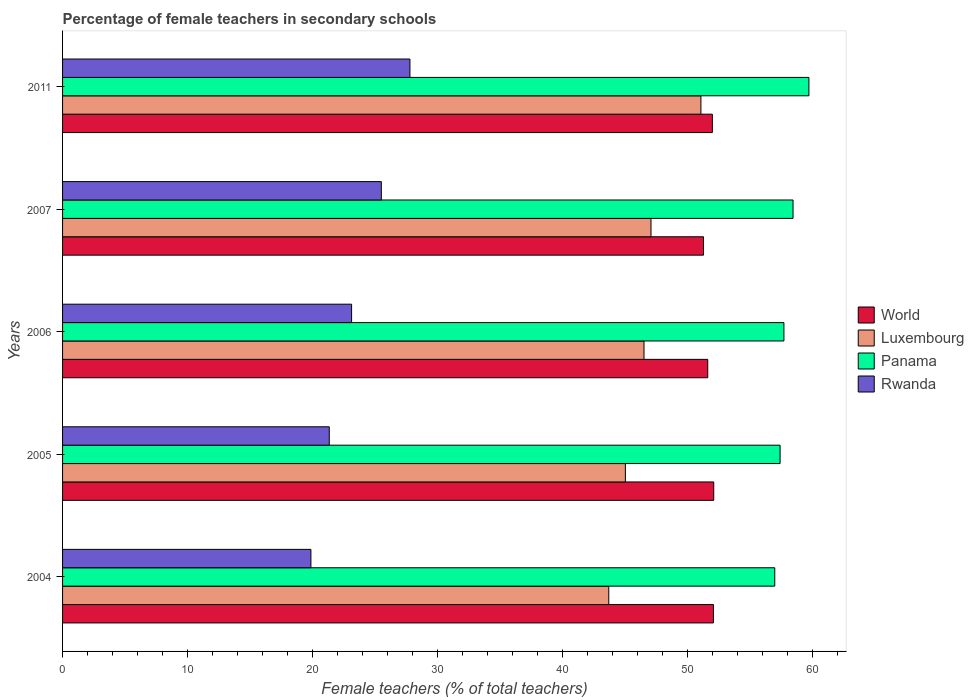How many groups of bars are there?
Your response must be concise. 5. Are the number of bars per tick equal to the number of legend labels?
Make the answer very short. Yes. Are the number of bars on each tick of the Y-axis equal?
Ensure brevity in your answer.  Yes. How many bars are there on the 5th tick from the top?
Keep it short and to the point. 4. How many bars are there on the 4th tick from the bottom?
Your answer should be very brief. 4. What is the label of the 4th group of bars from the top?
Give a very brief answer. 2005. What is the percentage of female teachers in Rwanda in 2004?
Give a very brief answer. 19.87. Across all years, what is the maximum percentage of female teachers in Rwanda?
Provide a succinct answer. 27.79. Across all years, what is the minimum percentage of female teachers in Rwanda?
Offer a very short reply. 19.87. In which year was the percentage of female teachers in Luxembourg maximum?
Provide a short and direct response. 2011. In which year was the percentage of female teachers in Panama minimum?
Your response must be concise. 2004. What is the total percentage of female teachers in Rwanda in the graph?
Ensure brevity in your answer.  117.64. What is the difference between the percentage of female teachers in Luxembourg in 2004 and that in 2007?
Provide a short and direct response. -3.38. What is the difference between the percentage of female teachers in World in 2004 and the percentage of female teachers in Luxembourg in 2005?
Your answer should be compact. 7.05. What is the average percentage of female teachers in Luxembourg per year?
Ensure brevity in your answer.  46.68. In the year 2004, what is the difference between the percentage of female teachers in Panama and percentage of female teachers in Rwanda?
Keep it short and to the point. 37.12. In how many years, is the percentage of female teachers in Rwanda greater than 50 %?
Your answer should be very brief. 0. What is the ratio of the percentage of female teachers in Panama in 2004 to that in 2011?
Offer a very short reply. 0.95. What is the difference between the highest and the second highest percentage of female teachers in Rwanda?
Your answer should be very brief. 2.29. What is the difference between the highest and the lowest percentage of female teachers in Rwanda?
Provide a succinct answer. 7.92. In how many years, is the percentage of female teachers in Panama greater than the average percentage of female teachers in Panama taken over all years?
Offer a terse response. 2. Is the sum of the percentage of female teachers in World in 2006 and 2007 greater than the maximum percentage of female teachers in Panama across all years?
Your answer should be compact. Yes. What does the 2nd bar from the top in 2007 represents?
Offer a terse response. Panama. What does the 3rd bar from the bottom in 2006 represents?
Offer a terse response. Panama. Is it the case that in every year, the sum of the percentage of female teachers in World and percentage of female teachers in Luxembourg is greater than the percentage of female teachers in Panama?
Offer a very short reply. Yes. What is the difference between two consecutive major ticks on the X-axis?
Ensure brevity in your answer.  10. Does the graph contain grids?
Your answer should be very brief. No. Where does the legend appear in the graph?
Give a very brief answer. Center right. What is the title of the graph?
Ensure brevity in your answer.  Percentage of female teachers in secondary schools. Does "Northern Mariana Islands" appear as one of the legend labels in the graph?
Provide a short and direct response. No. What is the label or title of the X-axis?
Your answer should be compact. Female teachers (% of total teachers). What is the Female teachers (% of total teachers) of World in 2004?
Offer a very short reply. 52.08. What is the Female teachers (% of total teachers) of Luxembourg in 2004?
Offer a very short reply. 43.7. What is the Female teachers (% of total teachers) of Panama in 2004?
Ensure brevity in your answer.  56.99. What is the Female teachers (% of total teachers) in Rwanda in 2004?
Ensure brevity in your answer.  19.87. What is the Female teachers (% of total teachers) of World in 2005?
Give a very brief answer. 52.1. What is the Female teachers (% of total teachers) of Luxembourg in 2005?
Your response must be concise. 45.03. What is the Female teachers (% of total teachers) in Panama in 2005?
Ensure brevity in your answer.  57.41. What is the Female teachers (% of total teachers) in Rwanda in 2005?
Ensure brevity in your answer.  21.34. What is the Female teachers (% of total teachers) of World in 2006?
Keep it short and to the point. 51.62. What is the Female teachers (% of total teachers) in Luxembourg in 2006?
Your response must be concise. 46.52. What is the Female teachers (% of total teachers) of Panama in 2006?
Your answer should be very brief. 57.72. What is the Female teachers (% of total teachers) in Rwanda in 2006?
Your response must be concise. 23.13. What is the Female teachers (% of total teachers) of World in 2007?
Offer a very short reply. 51.28. What is the Female teachers (% of total teachers) in Luxembourg in 2007?
Offer a very short reply. 47.08. What is the Female teachers (% of total teachers) in Panama in 2007?
Your response must be concise. 58.45. What is the Female teachers (% of total teachers) of Rwanda in 2007?
Offer a terse response. 25.51. What is the Female teachers (% of total teachers) in World in 2011?
Provide a succinct answer. 51.99. What is the Female teachers (% of total teachers) in Luxembourg in 2011?
Give a very brief answer. 51.08. What is the Female teachers (% of total teachers) in Panama in 2011?
Give a very brief answer. 59.72. What is the Female teachers (% of total teachers) of Rwanda in 2011?
Make the answer very short. 27.79. Across all years, what is the maximum Female teachers (% of total teachers) of World?
Your answer should be very brief. 52.1. Across all years, what is the maximum Female teachers (% of total teachers) of Luxembourg?
Provide a short and direct response. 51.08. Across all years, what is the maximum Female teachers (% of total teachers) in Panama?
Your answer should be compact. 59.72. Across all years, what is the maximum Female teachers (% of total teachers) of Rwanda?
Ensure brevity in your answer.  27.79. Across all years, what is the minimum Female teachers (% of total teachers) in World?
Provide a short and direct response. 51.28. Across all years, what is the minimum Female teachers (% of total teachers) in Luxembourg?
Offer a terse response. 43.7. Across all years, what is the minimum Female teachers (% of total teachers) in Panama?
Ensure brevity in your answer.  56.99. Across all years, what is the minimum Female teachers (% of total teachers) of Rwanda?
Offer a very short reply. 19.87. What is the total Female teachers (% of total teachers) in World in the graph?
Your answer should be very brief. 259.08. What is the total Female teachers (% of total teachers) in Luxembourg in the graph?
Offer a very short reply. 233.42. What is the total Female teachers (% of total teachers) of Panama in the graph?
Your answer should be compact. 290.29. What is the total Female teachers (% of total teachers) of Rwanda in the graph?
Make the answer very short. 117.64. What is the difference between the Female teachers (% of total teachers) in World in 2004 and that in 2005?
Your response must be concise. -0.02. What is the difference between the Female teachers (% of total teachers) of Luxembourg in 2004 and that in 2005?
Keep it short and to the point. -1.33. What is the difference between the Female teachers (% of total teachers) in Panama in 2004 and that in 2005?
Ensure brevity in your answer.  -0.43. What is the difference between the Female teachers (% of total teachers) in Rwanda in 2004 and that in 2005?
Ensure brevity in your answer.  -1.47. What is the difference between the Female teachers (% of total teachers) of World in 2004 and that in 2006?
Keep it short and to the point. 0.45. What is the difference between the Female teachers (% of total teachers) in Luxembourg in 2004 and that in 2006?
Provide a succinct answer. -2.82. What is the difference between the Female teachers (% of total teachers) of Panama in 2004 and that in 2006?
Your answer should be compact. -0.73. What is the difference between the Female teachers (% of total teachers) of Rwanda in 2004 and that in 2006?
Your response must be concise. -3.26. What is the difference between the Female teachers (% of total teachers) of World in 2004 and that in 2007?
Your answer should be very brief. 0.8. What is the difference between the Female teachers (% of total teachers) in Luxembourg in 2004 and that in 2007?
Your answer should be compact. -3.38. What is the difference between the Female teachers (% of total teachers) of Panama in 2004 and that in 2007?
Offer a terse response. -1.46. What is the difference between the Female teachers (% of total teachers) in Rwanda in 2004 and that in 2007?
Give a very brief answer. -5.64. What is the difference between the Female teachers (% of total teachers) in World in 2004 and that in 2011?
Make the answer very short. 0.09. What is the difference between the Female teachers (% of total teachers) in Luxembourg in 2004 and that in 2011?
Give a very brief answer. -7.37. What is the difference between the Female teachers (% of total teachers) in Panama in 2004 and that in 2011?
Offer a very short reply. -2.73. What is the difference between the Female teachers (% of total teachers) of Rwanda in 2004 and that in 2011?
Make the answer very short. -7.92. What is the difference between the Female teachers (% of total teachers) in World in 2005 and that in 2006?
Keep it short and to the point. 0.48. What is the difference between the Female teachers (% of total teachers) in Luxembourg in 2005 and that in 2006?
Keep it short and to the point. -1.49. What is the difference between the Female teachers (% of total teachers) in Panama in 2005 and that in 2006?
Offer a very short reply. -0.31. What is the difference between the Female teachers (% of total teachers) of Rwanda in 2005 and that in 2006?
Your response must be concise. -1.79. What is the difference between the Female teachers (% of total teachers) of World in 2005 and that in 2007?
Offer a very short reply. 0.82. What is the difference between the Female teachers (% of total teachers) of Luxembourg in 2005 and that in 2007?
Your answer should be compact. -2.05. What is the difference between the Female teachers (% of total teachers) in Panama in 2005 and that in 2007?
Provide a succinct answer. -1.04. What is the difference between the Female teachers (% of total teachers) in Rwanda in 2005 and that in 2007?
Offer a very short reply. -4.17. What is the difference between the Female teachers (% of total teachers) of World in 2005 and that in 2011?
Make the answer very short. 0.11. What is the difference between the Female teachers (% of total teachers) in Luxembourg in 2005 and that in 2011?
Make the answer very short. -6.05. What is the difference between the Female teachers (% of total teachers) of Panama in 2005 and that in 2011?
Ensure brevity in your answer.  -2.31. What is the difference between the Female teachers (% of total teachers) of Rwanda in 2005 and that in 2011?
Offer a terse response. -6.45. What is the difference between the Female teachers (% of total teachers) in World in 2006 and that in 2007?
Keep it short and to the point. 0.34. What is the difference between the Female teachers (% of total teachers) of Luxembourg in 2006 and that in 2007?
Offer a very short reply. -0.56. What is the difference between the Female teachers (% of total teachers) in Panama in 2006 and that in 2007?
Make the answer very short. -0.73. What is the difference between the Female teachers (% of total teachers) in Rwanda in 2006 and that in 2007?
Offer a very short reply. -2.38. What is the difference between the Female teachers (% of total teachers) in World in 2006 and that in 2011?
Your response must be concise. -0.37. What is the difference between the Female teachers (% of total teachers) in Luxembourg in 2006 and that in 2011?
Make the answer very short. -4.56. What is the difference between the Female teachers (% of total teachers) in Panama in 2006 and that in 2011?
Offer a very short reply. -2. What is the difference between the Female teachers (% of total teachers) of Rwanda in 2006 and that in 2011?
Make the answer very short. -4.67. What is the difference between the Female teachers (% of total teachers) of World in 2007 and that in 2011?
Your response must be concise. -0.71. What is the difference between the Female teachers (% of total teachers) in Luxembourg in 2007 and that in 2011?
Offer a very short reply. -3.99. What is the difference between the Female teachers (% of total teachers) in Panama in 2007 and that in 2011?
Ensure brevity in your answer.  -1.27. What is the difference between the Female teachers (% of total teachers) in Rwanda in 2007 and that in 2011?
Offer a very short reply. -2.29. What is the difference between the Female teachers (% of total teachers) of World in 2004 and the Female teachers (% of total teachers) of Luxembourg in 2005?
Offer a very short reply. 7.05. What is the difference between the Female teachers (% of total teachers) in World in 2004 and the Female teachers (% of total teachers) in Panama in 2005?
Your answer should be compact. -5.33. What is the difference between the Female teachers (% of total teachers) in World in 2004 and the Female teachers (% of total teachers) in Rwanda in 2005?
Ensure brevity in your answer.  30.74. What is the difference between the Female teachers (% of total teachers) of Luxembourg in 2004 and the Female teachers (% of total teachers) of Panama in 2005?
Give a very brief answer. -13.71. What is the difference between the Female teachers (% of total teachers) in Luxembourg in 2004 and the Female teachers (% of total teachers) in Rwanda in 2005?
Keep it short and to the point. 22.36. What is the difference between the Female teachers (% of total teachers) of Panama in 2004 and the Female teachers (% of total teachers) of Rwanda in 2005?
Give a very brief answer. 35.65. What is the difference between the Female teachers (% of total teachers) in World in 2004 and the Female teachers (% of total teachers) in Luxembourg in 2006?
Your answer should be compact. 5.56. What is the difference between the Female teachers (% of total teachers) in World in 2004 and the Female teachers (% of total teachers) in Panama in 2006?
Offer a very short reply. -5.64. What is the difference between the Female teachers (% of total teachers) of World in 2004 and the Female teachers (% of total teachers) of Rwanda in 2006?
Ensure brevity in your answer.  28.95. What is the difference between the Female teachers (% of total teachers) in Luxembourg in 2004 and the Female teachers (% of total teachers) in Panama in 2006?
Make the answer very short. -14.02. What is the difference between the Female teachers (% of total teachers) in Luxembourg in 2004 and the Female teachers (% of total teachers) in Rwanda in 2006?
Keep it short and to the point. 20.58. What is the difference between the Female teachers (% of total teachers) of Panama in 2004 and the Female teachers (% of total teachers) of Rwanda in 2006?
Provide a short and direct response. 33.86. What is the difference between the Female teachers (% of total teachers) in World in 2004 and the Female teachers (% of total teachers) in Luxembourg in 2007?
Ensure brevity in your answer.  5. What is the difference between the Female teachers (% of total teachers) of World in 2004 and the Female teachers (% of total teachers) of Panama in 2007?
Ensure brevity in your answer.  -6.37. What is the difference between the Female teachers (% of total teachers) of World in 2004 and the Female teachers (% of total teachers) of Rwanda in 2007?
Your answer should be very brief. 26.57. What is the difference between the Female teachers (% of total teachers) in Luxembourg in 2004 and the Female teachers (% of total teachers) in Panama in 2007?
Provide a succinct answer. -14.75. What is the difference between the Female teachers (% of total teachers) of Luxembourg in 2004 and the Female teachers (% of total teachers) of Rwanda in 2007?
Offer a terse response. 18.2. What is the difference between the Female teachers (% of total teachers) of Panama in 2004 and the Female teachers (% of total teachers) of Rwanda in 2007?
Provide a short and direct response. 31.48. What is the difference between the Female teachers (% of total teachers) of World in 2004 and the Female teachers (% of total teachers) of Panama in 2011?
Offer a terse response. -7.64. What is the difference between the Female teachers (% of total teachers) of World in 2004 and the Female teachers (% of total teachers) of Rwanda in 2011?
Your answer should be compact. 24.28. What is the difference between the Female teachers (% of total teachers) of Luxembourg in 2004 and the Female teachers (% of total teachers) of Panama in 2011?
Provide a short and direct response. -16.02. What is the difference between the Female teachers (% of total teachers) of Luxembourg in 2004 and the Female teachers (% of total teachers) of Rwanda in 2011?
Keep it short and to the point. 15.91. What is the difference between the Female teachers (% of total teachers) of Panama in 2004 and the Female teachers (% of total teachers) of Rwanda in 2011?
Ensure brevity in your answer.  29.19. What is the difference between the Female teachers (% of total teachers) in World in 2005 and the Female teachers (% of total teachers) in Luxembourg in 2006?
Ensure brevity in your answer.  5.58. What is the difference between the Female teachers (% of total teachers) of World in 2005 and the Female teachers (% of total teachers) of Panama in 2006?
Offer a terse response. -5.62. What is the difference between the Female teachers (% of total teachers) in World in 2005 and the Female teachers (% of total teachers) in Rwanda in 2006?
Make the answer very short. 28.98. What is the difference between the Female teachers (% of total teachers) in Luxembourg in 2005 and the Female teachers (% of total teachers) in Panama in 2006?
Make the answer very short. -12.69. What is the difference between the Female teachers (% of total teachers) in Luxembourg in 2005 and the Female teachers (% of total teachers) in Rwanda in 2006?
Offer a terse response. 21.91. What is the difference between the Female teachers (% of total teachers) of Panama in 2005 and the Female teachers (% of total teachers) of Rwanda in 2006?
Give a very brief answer. 34.29. What is the difference between the Female teachers (% of total teachers) in World in 2005 and the Female teachers (% of total teachers) in Luxembourg in 2007?
Provide a short and direct response. 5.02. What is the difference between the Female teachers (% of total teachers) in World in 2005 and the Female teachers (% of total teachers) in Panama in 2007?
Make the answer very short. -6.35. What is the difference between the Female teachers (% of total teachers) of World in 2005 and the Female teachers (% of total teachers) of Rwanda in 2007?
Your response must be concise. 26.6. What is the difference between the Female teachers (% of total teachers) of Luxembourg in 2005 and the Female teachers (% of total teachers) of Panama in 2007?
Provide a short and direct response. -13.42. What is the difference between the Female teachers (% of total teachers) in Luxembourg in 2005 and the Female teachers (% of total teachers) in Rwanda in 2007?
Your response must be concise. 19.53. What is the difference between the Female teachers (% of total teachers) of Panama in 2005 and the Female teachers (% of total teachers) of Rwanda in 2007?
Provide a succinct answer. 31.91. What is the difference between the Female teachers (% of total teachers) of World in 2005 and the Female teachers (% of total teachers) of Luxembourg in 2011?
Give a very brief answer. 1.02. What is the difference between the Female teachers (% of total teachers) in World in 2005 and the Female teachers (% of total teachers) in Panama in 2011?
Provide a short and direct response. -7.62. What is the difference between the Female teachers (% of total teachers) of World in 2005 and the Female teachers (% of total teachers) of Rwanda in 2011?
Your response must be concise. 24.31. What is the difference between the Female teachers (% of total teachers) in Luxembourg in 2005 and the Female teachers (% of total teachers) in Panama in 2011?
Provide a short and direct response. -14.69. What is the difference between the Female teachers (% of total teachers) in Luxembourg in 2005 and the Female teachers (% of total teachers) in Rwanda in 2011?
Your response must be concise. 17.24. What is the difference between the Female teachers (% of total teachers) of Panama in 2005 and the Female teachers (% of total teachers) of Rwanda in 2011?
Offer a very short reply. 29.62. What is the difference between the Female teachers (% of total teachers) of World in 2006 and the Female teachers (% of total teachers) of Luxembourg in 2007?
Offer a terse response. 4.54. What is the difference between the Female teachers (% of total teachers) in World in 2006 and the Female teachers (% of total teachers) in Panama in 2007?
Your answer should be compact. -6.83. What is the difference between the Female teachers (% of total teachers) of World in 2006 and the Female teachers (% of total teachers) of Rwanda in 2007?
Your answer should be compact. 26.12. What is the difference between the Female teachers (% of total teachers) in Luxembourg in 2006 and the Female teachers (% of total teachers) in Panama in 2007?
Offer a terse response. -11.93. What is the difference between the Female teachers (% of total teachers) of Luxembourg in 2006 and the Female teachers (% of total teachers) of Rwanda in 2007?
Offer a very short reply. 21.02. What is the difference between the Female teachers (% of total teachers) in Panama in 2006 and the Female teachers (% of total teachers) in Rwanda in 2007?
Provide a short and direct response. 32.21. What is the difference between the Female teachers (% of total teachers) in World in 2006 and the Female teachers (% of total teachers) in Luxembourg in 2011?
Provide a short and direct response. 0.55. What is the difference between the Female teachers (% of total teachers) in World in 2006 and the Female teachers (% of total teachers) in Panama in 2011?
Give a very brief answer. -8.09. What is the difference between the Female teachers (% of total teachers) of World in 2006 and the Female teachers (% of total teachers) of Rwanda in 2011?
Offer a terse response. 23.83. What is the difference between the Female teachers (% of total teachers) of Luxembourg in 2006 and the Female teachers (% of total teachers) of Panama in 2011?
Provide a succinct answer. -13.2. What is the difference between the Female teachers (% of total teachers) in Luxembourg in 2006 and the Female teachers (% of total teachers) in Rwanda in 2011?
Offer a very short reply. 18.73. What is the difference between the Female teachers (% of total teachers) of Panama in 2006 and the Female teachers (% of total teachers) of Rwanda in 2011?
Make the answer very short. 29.92. What is the difference between the Female teachers (% of total teachers) of World in 2007 and the Female teachers (% of total teachers) of Luxembourg in 2011?
Make the answer very short. 0.21. What is the difference between the Female teachers (% of total teachers) of World in 2007 and the Female teachers (% of total teachers) of Panama in 2011?
Keep it short and to the point. -8.43. What is the difference between the Female teachers (% of total teachers) in World in 2007 and the Female teachers (% of total teachers) in Rwanda in 2011?
Your answer should be very brief. 23.49. What is the difference between the Female teachers (% of total teachers) of Luxembourg in 2007 and the Female teachers (% of total teachers) of Panama in 2011?
Your answer should be very brief. -12.63. What is the difference between the Female teachers (% of total teachers) in Luxembourg in 2007 and the Female teachers (% of total teachers) in Rwanda in 2011?
Provide a succinct answer. 19.29. What is the difference between the Female teachers (% of total teachers) of Panama in 2007 and the Female teachers (% of total teachers) of Rwanda in 2011?
Ensure brevity in your answer.  30.66. What is the average Female teachers (% of total teachers) of World per year?
Offer a very short reply. 51.82. What is the average Female teachers (% of total teachers) in Luxembourg per year?
Your response must be concise. 46.68. What is the average Female teachers (% of total teachers) in Panama per year?
Offer a very short reply. 58.06. What is the average Female teachers (% of total teachers) in Rwanda per year?
Ensure brevity in your answer.  23.53. In the year 2004, what is the difference between the Female teachers (% of total teachers) of World and Female teachers (% of total teachers) of Luxembourg?
Make the answer very short. 8.38. In the year 2004, what is the difference between the Female teachers (% of total teachers) in World and Female teachers (% of total teachers) in Panama?
Your answer should be very brief. -4.91. In the year 2004, what is the difference between the Female teachers (% of total teachers) in World and Female teachers (% of total teachers) in Rwanda?
Provide a short and direct response. 32.21. In the year 2004, what is the difference between the Female teachers (% of total teachers) in Luxembourg and Female teachers (% of total teachers) in Panama?
Your answer should be compact. -13.28. In the year 2004, what is the difference between the Female teachers (% of total teachers) in Luxembourg and Female teachers (% of total teachers) in Rwanda?
Make the answer very short. 23.83. In the year 2004, what is the difference between the Female teachers (% of total teachers) in Panama and Female teachers (% of total teachers) in Rwanda?
Provide a succinct answer. 37.12. In the year 2005, what is the difference between the Female teachers (% of total teachers) of World and Female teachers (% of total teachers) of Luxembourg?
Your answer should be compact. 7.07. In the year 2005, what is the difference between the Female teachers (% of total teachers) in World and Female teachers (% of total teachers) in Panama?
Make the answer very short. -5.31. In the year 2005, what is the difference between the Female teachers (% of total teachers) in World and Female teachers (% of total teachers) in Rwanda?
Ensure brevity in your answer.  30.76. In the year 2005, what is the difference between the Female teachers (% of total teachers) in Luxembourg and Female teachers (% of total teachers) in Panama?
Provide a short and direct response. -12.38. In the year 2005, what is the difference between the Female teachers (% of total teachers) of Luxembourg and Female teachers (% of total teachers) of Rwanda?
Ensure brevity in your answer.  23.69. In the year 2005, what is the difference between the Female teachers (% of total teachers) in Panama and Female teachers (% of total teachers) in Rwanda?
Make the answer very short. 36.07. In the year 2006, what is the difference between the Female teachers (% of total teachers) of World and Female teachers (% of total teachers) of Luxembourg?
Give a very brief answer. 5.1. In the year 2006, what is the difference between the Female teachers (% of total teachers) of World and Female teachers (% of total teachers) of Panama?
Keep it short and to the point. -6.09. In the year 2006, what is the difference between the Female teachers (% of total teachers) of World and Female teachers (% of total teachers) of Rwanda?
Offer a terse response. 28.5. In the year 2006, what is the difference between the Female teachers (% of total teachers) in Luxembourg and Female teachers (% of total teachers) in Panama?
Provide a succinct answer. -11.2. In the year 2006, what is the difference between the Female teachers (% of total teachers) of Luxembourg and Female teachers (% of total teachers) of Rwanda?
Provide a short and direct response. 23.4. In the year 2006, what is the difference between the Female teachers (% of total teachers) of Panama and Female teachers (% of total teachers) of Rwanda?
Offer a very short reply. 34.59. In the year 2007, what is the difference between the Female teachers (% of total teachers) in World and Female teachers (% of total teachers) in Luxembourg?
Ensure brevity in your answer.  4.2. In the year 2007, what is the difference between the Female teachers (% of total teachers) of World and Female teachers (% of total teachers) of Panama?
Provide a short and direct response. -7.17. In the year 2007, what is the difference between the Female teachers (% of total teachers) in World and Female teachers (% of total teachers) in Rwanda?
Give a very brief answer. 25.78. In the year 2007, what is the difference between the Female teachers (% of total teachers) in Luxembourg and Female teachers (% of total teachers) in Panama?
Your answer should be compact. -11.37. In the year 2007, what is the difference between the Female teachers (% of total teachers) in Luxembourg and Female teachers (% of total teachers) in Rwanda?
Provide a short and direct response. 21.58. In the year 2007, what is the difference between the Female teachers (% of total teachers) of Panama and Female teachers (% of total teachers) of Rwanda?
Make the answer very short. 32.94. In the year 2011, what is the difference between the Female teachers (% of total teachers) of World and Female teachers (% of total teachers) of Luxembourg?
Offer a very short reply. 0.91. In the year 2011, what is the difference between the Female teachers (% of total teachers) of World and Female teachers (% of total teachers) of Panama?
Give a very brief answer. -7.73. In the year 2011, what is the difference between the Female teachers (% of total teachers) of World and Female teachers (% of total teachers) of Rwanda?
Provide a short and direct response. 24.2. In the year 2011, what is the difference between the Female teachers (% of total teachers) in Luxembourg and Female teachers (% of total teachers) in Panama?
Your response must be concise. -8.64. In the year 2011, what is the difference between the Female teachers (% of total teachers) in Luxembourg and Female teachers (% of total teachers) in Rwanda?
Provide a succinct answer. 23.28. In the year 2011, what is the difference between the Female teachers (% of total teachers) of Panama and Female teachers (% of total teachers) of Rwanda?
Provide a succinct answer. 31.92. What is the ratio of the Female teachers (% of total teachers) of World in 2004 to that in 2005?
Your answer should be compact. 1. What is the ratio of the Female teachers (% of total teachers) in Luxembourg in 2004 to that in 2005?
Offer a very short reply. 0.97. What is the ratio of the Female teachers (% of total teachers) of Rwanda in 2004 to that in 2005?
Your answer should be compact. 0.93. What is the ratio of the Female teachers (% of total teachers) of World in 2004 to that in 2006?
Ensure brevity in your answer.  1.01. What is the ratio of the Female teachers (% of total teachers) in Luxembourg in 2004 to that in 2006?
Your answer should be compact. 0.94. What is the ratio of the Female teachers (% of total teachers) in Panama in 2004 to that in 2006?
Give a very brief answer. 0.99. What is the ratio of the Female teachers (% of total teachers) of Rwanda in 2004 to that in 2006?
Your response must be concise. 0.86. What is the ratio of the Female teachers (% of total teachers) of World in 2004 to that in 2007?
Ensure brevity in your answer.  1.02. What is the ratio of the Female teachers (% of total teachers) in Luxembourg in 2004 to that in 2007?
Give a very brief answer. 0.93. What is the ratio of the Female teachers (% of total teachers) of Rwanda in 2004 to that in 2007?
Your answer should be compact. 0.78. What is the ratio of the Female teachers (% of total teachers) of World in 2004 to that in 2011?
Your answer should be very brief. 1. What is the ratio of the Female teachers (% of total teachers) in Luxembourg in 2004 to that in 2011?
Provide a succinct answer. 0.86. What is the ratio of the Female teachers (% of total teachers) of Panama in 2004 to that in 2011?
Your response must be concise. 0.95. What is the ratio of the Female teachers (% of total teachers) in Rwanda in 2004 to that in 2011?
Give a very brief answer. 0.71. What is the ratio of the Female teachers (% of total teachers) in World in 2005 to that in 2006?
Provide a short and direct response. 1.01. What is the ratio of the Female teachers (% of total teachers) of Panama in 2005 to that in 2006?
Offer a very short reply. 0.99. What is the ratio of the Female teachers (% of total teachers) in Rwanda in 2005 to that in 2006?
Give a very brief answer. 0.92. What is the ratio of the Female teachers (% of total teachers) of World in 2005 to that in 2007?
Your response must be concise. 1.02. What is the ratio of the Female teachers (% of total teachers) of Luxembourg in 2005 to that in 2007?
Give a very brief answer. 0.96. What is the ratio of the Female teachers (% of total teachers) of Panama in 2005 to that in 2007?
Offer a very short reply. 0.98. What is the ratio of the Female teachers (% of total teachers) in Rwanda in 2005 to that in 2007?
Keep it short and to the point. 0.84. What is the ratio of the Female teachers (% of total teachers) in World in 2005 to that in 2011?
Your answer should be very brief. 1. What is the ratio of the Female teachers (% of total teachers) in Luxembourg in 2005 to that in 2011?
Your answer should be very brief. 0.88. What is the ratio of the Female teachers (% of total teachers) in Panama in 2005 to that in 2011?
Ensure brevity in your answer.  0.96. What is the ratio of the Female teachers (% of total teachers) of Rwanda in 2005 to that in 2011?
Ensure brevity in your answer.  0.77. What is the ratio of the Female teachers (% of total teachers) in World in 2006 to that in 2007?
Offer a terse response. 1.01. What is the ratio of the Female teachers (% of total teachers) in Panama in 2006 to that in 2007?
Provide a succinct answer. 0.99. What is the ratio of the Female teachers (% of total teachers) of Rwanda in 2006 to that in 2007?
Ensure brevity in your answer.  0.91. What is the ratio of the Female teachers (% of total teachers) in World in 2006 to that in 2011?
Your answer should be very brief. 0.99. What is the ratio of the Female teachers (% of total teachers) of Luxembourg in 2006 to that in 2011?
Make the answer very short. 0.91. What is the ratio of the Female teachers (% of total teachers) in Panama in 2006 to that in 2011?
Offer a terse response. 0.97. What is the ratio of the Female teachers (% of total teachers) of Rwanda in 2006 to that in 2011?
Keep it short and to the point. 0.83. What is the ratio of the Female teachers (% of total teachers) in World in 2007 to that in 2011?
Provide a succinct answer. 0.99. What is the ratio of the Female teachers (% of total teachers) of Luxembourg in 2007 to that in 2011?
Provide a succinct answer. 0.92. What is the ratio of the Female teachers (% of total teachers) of Panama in 2007 to that in 2011?
Your response must be concise. 0.98. What is the ratio of the Female teachers (% of total teachers) in Rwanda in 2007 to that in 2011?
Your response must be concise. 0.92. What is the difference between the highest and the second highest Female teachers (% of total teachers) in World?
Offer a very short reply. 0.02. What is the difference between the highest and the second highest Female teachers (% of total teachers) in Luxembourg?
Your answer should be compact. 3.99. What is the difference between the highest and the second highest Female teachers (% of total teachers) in Panama?
Provide a short and direct response. 1.27. What is the difference between the highest and the second highest Female teachers (% of total teachers) of Rwanda?
Keep it short and to the point. 2.29. What is the difference between the highest and the lowest Female teachers (% of total teachers) of World?
Offer a terse response. 0.82. What is the difference between the highest and the lowest Female teachers (% of total teachers) in Luxembourg?
Ensure brevity in your answer.  7.37. What is the difference between the highest and the lowest Female teachers (% of total teachers) in Panama?
Keep it short and to the point. 2.73. What is the difference between the highest and the lowest Female teachers (% of total teachers) in Rwanda?
Provide a succinct answer. 7.92. 